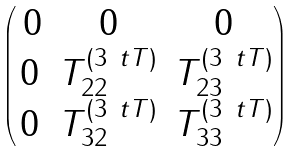Convert formula to latex. <formula><loc_0><loc_0><loc_500><loc_500>\begin{pmatrix} \, 0 & 0 & 0 \\ 0 & T ^ { ( 3 \ t T ) } _ { 2 2 } & T ^ { ( 3 \ t T ) } _ { 2 3 } \\ 0 & T ^ { ( 3 \ t T ) } _ { 3 2 } & T ^ { ( 3 \ t T ) } _ { 3 3 } \end{pmatrix}</formula> 